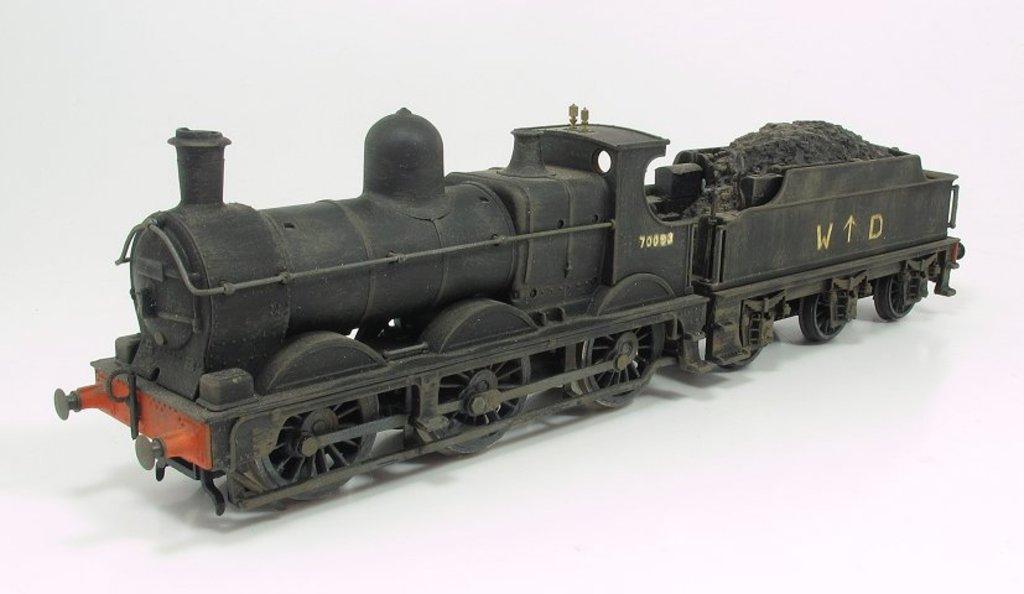How would you summarize this image in a sentence or two? As we can see in the image there is a black color toy train. 